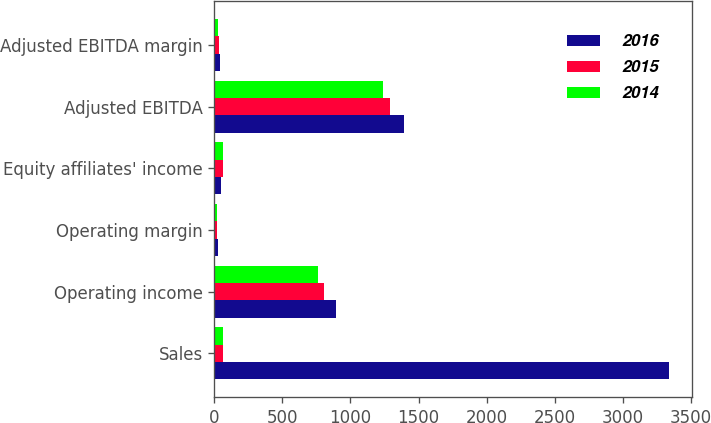<chart> <loc_0><loc_0><loc_500><loc_500><stacked_bar_chart><ecel><fcel>Sales<fcel>Operating income<fcel>Operating margin<fcel>Equity affiliates' income<fcel>Adjusted EBITDA<fcel>Adjusted EBITDA margin<nl><fcel>2016<fcel>3343.6<fcel>895.2<fcel>26.8<fcel>52.7<fcel>1390.4<fcel>41.6<nl><fcel>2015<fcel>62.75<fcel>808.4<fcel>21.9<fcel>64.6<fcel>1289.9<fcel>34.9<nl><fcel>2014<fcel>62.75<fcel>762.6<fcel>18.7<fcel>60.9<fcel>1237.9<fcel>30.4<nl></chart> 